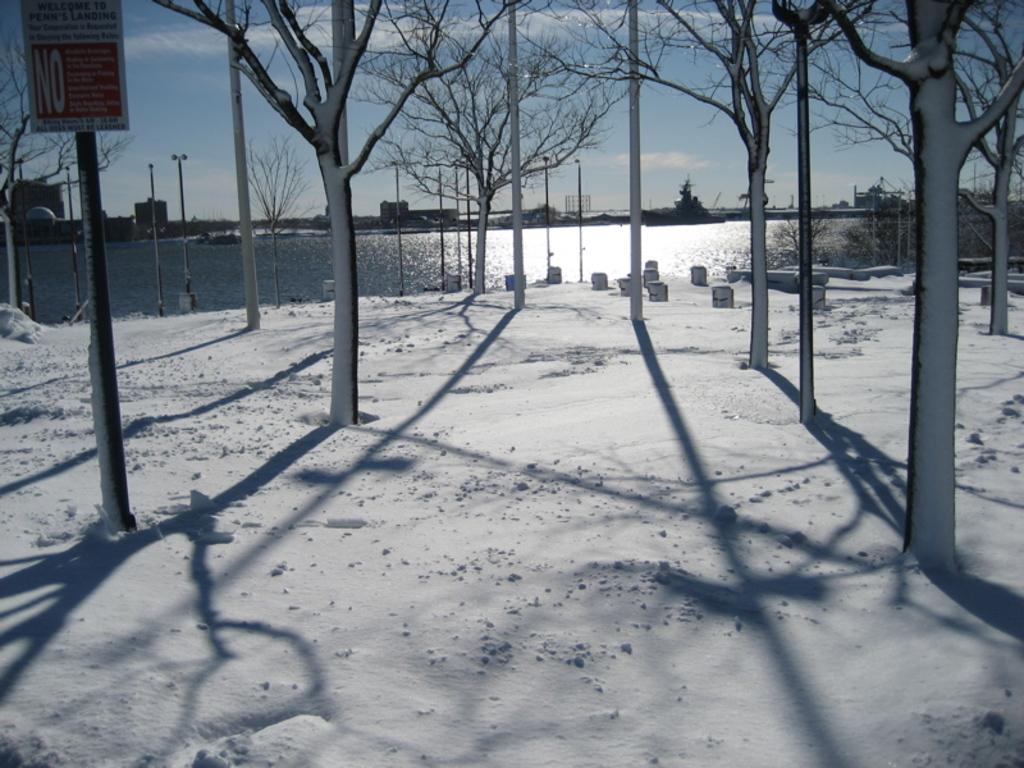What type of vegetation can be seen in the image? There are trees in the image. What is the condition of the land in the image? The land is covered with snow. What can be seen in the background of the image? The background of the image includes a sea. Where is the sign board located in the image? The sign board is on the left side of the image. What is associated with the sign board in the image? There is a pole associated with the sign board. What type of breakfast is being served in the image? There is no breakfast present in the image; it features trees, snow-covered land, a sea, a sign board, and a pole. Can you tell me where the church is located in the image? There is no church present in the image. 